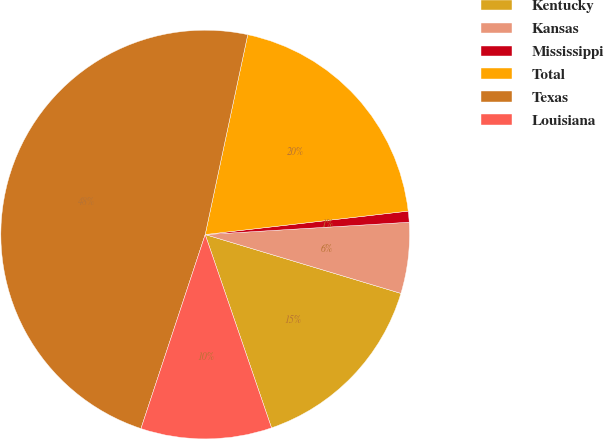<chart> <loc_0><loc_0><loc_500><loc_500><pie_chart><fcel>Kentucky<fcel>Kansas<fcel>Mississippi<fcel>Total<fcel>Texas<fcel>Louisiana<nl><fcel>15.09%<fcel>5.61%<fcel>0.87%<fcel>19.83%<fcel>48.25%<fcel>10.35%<nl></chart> 